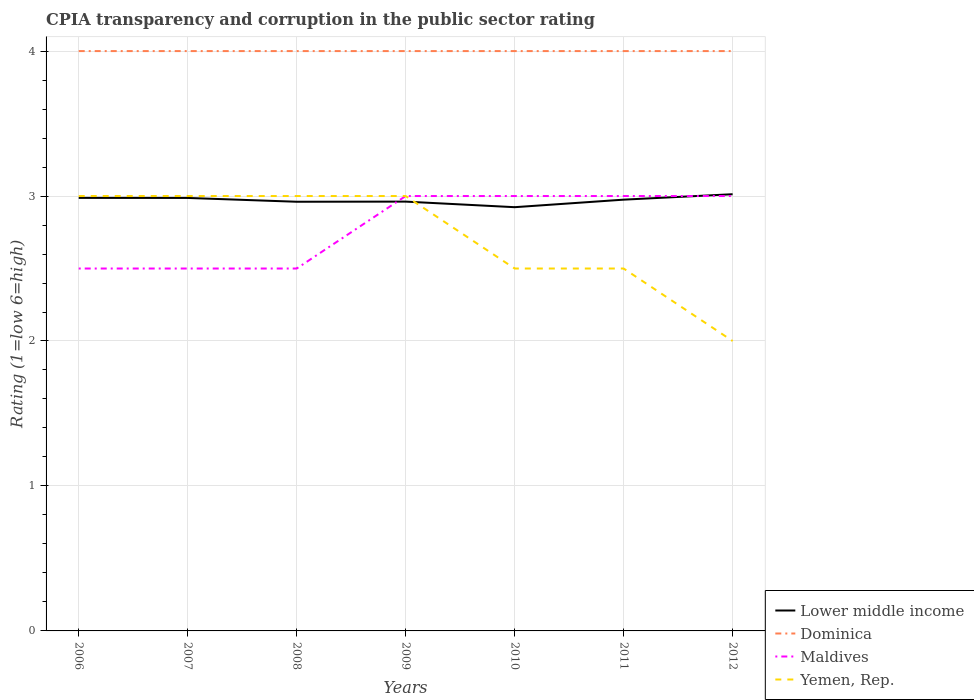Is the number of lines equal to the number of legend labels?
Your answer should be very brief. Yes. Across all years, what is the maximum CPIA rating in Lower middle income?
Your answer should be very brief. 2.92. In which year was the CPIA rating in Maldives maximum?
Ensure brevity in your answer.  2006. What is the total CPIA rating in Maldives in the graph?
Ensure brevity in your answer.  -0.5. What is the difference between the highest and the second highest CPIA rating in Lower middle income?
Provide a short and direct response. 0.09. What is the difference between the highest and the lowest CPIA rating in Maldives?
Offer a terse response. 4. Is the CPIA rating in Dominica strictly greater than the CPIA rating in Yemen, Rep. over the years?
Provide a succinct answer. No. How many years are there in the graph?
Your response must be concise. 7. What is the difference between two consecutive major ticks on the Y-axis?
Your answer should be compact. 1. Does the graph contain grids?
Provide a short and direct response. Yes. How are the legend labels stacked?
Make the answer very short. Vertical. What is the title of the graph?
Make the answer very short. CPIA transparency and corruption in the public sector rating. What is the label or title of the X-axis?
Your response must be concise. Years. What is the Rating (1=low 6=high) in Lower middle income in 2006?
Your response must be concise. 2.99. What is the Rating (1=low 6=high) of Dominica in 2006?
Offer a very short reply. 4. What is the Rating (1=low 6=high) of Yemen, Rep. in 2006?
Offer a very short reply. 3. What is the Rating (1=low 6=high) of Lower middle income in 2007?
Your answer should be compact. 2.99. What is the Rating (1=low 6=high) in Maldives in 2007?
Ensure brevity in your answer.  2.5. What is the Rating (1=low 6=high) in Yemen, Rep. in 2007?
Give a very brief answer. 3. What is the Rating (1=low 6=high) of Lower middle income in 2008?
Provide a short and direct response. 2.96. What is the Rating (1=low 6=high) of Maldives in 2008?
Provide a succinct answer. 2.5. What is the Rating (1=low 6=high) in Yemen, Rep. in 2008?
Offer a terse response. 3. What is the Rating (1=low 6=high) in Lower middle income in 2009?
Your response must be concise. 2.96. What is the Rating (1=low 6=high) of Maldives in 2009?
Offer a very short reply. 3. What is the Rating (1=low 6=high) in Lower middle income in 2010?
Provide a short and direct response. 2.92. What is the Rating (1=low 6=high) in Maldives in 2010?
Offer a terse response. 3. What is the Rating (1=low 6=high) of Yemen, Rep. in 2010?
Your answer should be compact. 2.5. What is the Rating (1=low 6=high) in Lower middle income in 2011?
Ensure brevity in your answer.  2.98. What is the Rating (1=low 6=high) in Maldives in 2011?
Ensure brevity in your answer.  3. What is the Rating (1=low 6=high) of Yemen, Rep. in 2011?
Make the answer very short. 2.5. What is the Rating (1=low 6=high) of Lower middle income in 2012?
Provide a short and direct response. 3.01. What is the Rating (1=low 6=high) of Yemen, Rep. in 2012?
Your answer should be compact. 2. Across all years, what is the maximum Rating (1=low 6=high) of Lower middle income?
Provide a succinct answer. 3.01. Across all years, what is the maximum Rating (1=low 6=high) of Dominica?
Your response must be concise. 4. Across all years, what is the maximum Rating (1=low 6=high) of Yemen, Rep.?
Your response must be concise. 3. Across all years, what is the minimum Rating (1=low 6=high) of Lower middle income?
Provide a succinct answer. 2.92. Across all years, what is the minimum Rating (1=low 6=high) of Maldives?
Keep it short and to the point. 2.5. Across all years, what is the minimum Rating (1=low 6=high) of Yemen, Rep.?
Provide a succinct answer. 2. What is the total Rating (1=low 6=high) in Lower middle income in the graph?
Offer a terse response. 20.81. What is the total Rating (1=low 6=high) in Maldives in the graph?
Provide a succinct answer. 19.5. What is the total Rating (1=low 6=high) in Yemen, Rep. in the graph?
Keep it short and to the point. 19. What is the difference between the Rating (1=low 6=high) in Yemen, Rep. in 2006 and that in 2007?
Give a very brief answer. 0. What is the difference between the Rating (1=low 6=high) in Lower middle income in 2006 and that in 2008?
Provide a short and direct response. 0.03. What is the difference between the Rating (1=low 6=high) in Yemen, Rep. in 2006 and that in 2008?
Give a very brief answer. 0. What is the difference between the Rating (1=low 6=high) of Lower middle income in 2006 and that in 2009?
Offer a terse response. 0.03. What is the difference between the Rating (1=low 6=high) of Dominica in 2006 and that in 2009?
Ensure brevity in your answer.  0. What is the difference between the Rating (1=low 6=high) in Maldives in 2006 and that in 2009?
Your response must be concise. -0.5. What is the difference between the Rating (1=low 6=high) in Lower middle income in 2006 and that in 2010?
Ensure brevity in your answer.  0.06. What is the difference between the Rating (1=low 6=high) in Yemen, Rep. in 2006 and that in 2010?
Your answer should be compact. 0.5. What is the difference between the Rating (1=low 6=high) in Lower middle income in 2006 and that in 2011?
Offer a very short reply. 0.01. What is the difference between the Rating (1=low 6=high) of Dominica in 2006 and that in 2011?
Your answer should be very brief. 0. What is the difference between the Rating (1=low 6=high) of Yemen, Rep. in 2006 and that in 2011?
Your response must be concise. 0.5. What is the difference between the Rating (1=low 6=high) of Lower middle income in 2006 and that in 2012?
Provide a short and direct response. -0.03. What is the difference between the Rating (1=low 6=high) in Lower middle income in 2007 and that in 2008?
Provide a succinct answer. 0.03. What is the difference between the Rating (1=low 6=high) of Yemen, Rep. in 2007 and that in 2008?
Your answer should be very brief. 0. What is the difference between the Rating (1=low 6=high) in Lower middle income in 2007 and that in 2009?
Your answer should be compact. 0.03. What is the difference between the Rating (1=low 6=high) in Maldives in 2007 and that in 2009?
Provide a short and direct response. -0.5. What is the difference between the Rating (1=low 6=high) in Yemen, Rep. in 2007 and that in 2009?
Offer a terse response. 0. What is the difference between the Rating (1=low 6=high) in Lower middle income in 2007 and that in 2010?
Your answer should be very brief. 0.06. What is the difference between the Rating (1=low 6=high) in Dominica in 2007 and that in 2010?
Offer a very short reply. 0. What is the difference between the Rating (1=low 6=high) of Lower middle income in 2007 and that in 2011?
Your answer should be compact. 0.01. What is the difference between the Rating (1=low 6=high) in Maldives in 2007 and that in 2011?
Ensure brevity in your answer.  -0.5. What is the difference between the Rating (1=low 6=high) of Yemen, Rep. in 2007 and that in 2011?
Keep it short and to the point. 0.5. What is the difference between the Rating (1=low 6=high) in Lower middle income in 2007 and that in 2012?
Ensure brevity in your answer.  -0.03. What is the difference between the Rating (1=low 6=high) in Dominica in 2007 and that in 2012?
Your answer should be compact. 0. What is the difference between the Rating (1=low 6=high) of Lower middle income in 2008 and that in 2009?
Your answer should be very brief. -0. What is the difference between the Rating (1=low 6=high) in Dominica in 2008 and that in 2009?
Offer a very short reply. 0. What is the difference between the Rating (1=low 6=high) in Maldives in 2008 and that in 2009?
Make the answer very short. -0.5. What is the difference between the Rating (1=low 6=high) in Lower middle income in 2008 and that in 2010?
Offer a very short reply. 0.04. What is the difference between the Rating (1=low 6=high) in Dominica in 2008 and that in 2010?
Your response must be concise. 0. What is the difference between the Rating (1=low 6=high) of Yemen, Rep. in 2008 and that in 2010?
Your answer should be compact. 0.5. What is the difference between the Rating (1=low 6=high) of Lower middle income in 2008 and that in 2011?
Your answer should be very brief. -0.01. What is the difference between the Rating (1=low 6=high) in Yemen, Rep. in 2008 and that in 2011?
Your answer should be very brief. 0.5. What is the difference between the Rating (1=low 6=high) of Lower middle income in 2008 and that in 2012?
Provide a succinct answer. -0.05. What is the difference between the Rating (1=low 6=high) in Maldives in 2008 and that in 2012?
Give a very brief answer. -0.5. What is the difference between the Rating (1=low 6=high) in Yemen, Rep. in 2008 and that in 2012?
Offer a very short reply. 1. What is the difference between the Rating (1=low 6=high) of Lower middle income in 2009 and that in 2010?
Ensure brevity in your answer.  0.04. What is the difference between the Rating (1=low 6=high) of Dominica in 2009 and that in 2010?
Offer a terse response. 0. What is the difference between the Rating (1=low 6=high) of Maldives in 2009 and that in 2010?
Your response must be concise. 0. What is the difference between the Rating (1=low 6=high) of Lower middle income in 2009 and that in 2011?
Make the answer very short. -0.01. What is the difference between the Rating (1=low 6=high) of Yemen, Rep. in 2009 and that in 2011?
Make the answer very short. 0.5. What is the difference between the Rating (1=low 6=high) in Lower middle income in 2009 and that in 2012?
Your answer should be very brief. -0.05. What is the difference between the Rating (1=low 6=high) in Yemen, Rep. in 2009 and that in 2012?
Offer a terse response. 1. What is the difference between the Rating (1=low 6=high) in Lower middle income in 2010 and that in 2011?
Your response must be concise. -0.05. What is the difference between the Rating (1=low 6=high) of Dominica in 2010 and that in 2011?
Provide a short and direct response. 0. What is the difference between the Rating (1=low 6=high) of Maldives in 2010 and that in 2011?
Offer a very short reply. 0. What is the difference between the Rating (1=low 6=high) in Lower middle income in 2010 and that in 2012?
Your answer should be very brief. -0.09. What is the difference between the Rating (1=low 6=high) in Lower middle income in 2011 and that in 2012?
Provide a succinct answer. -0.04. What is the difference between the Rating (1=low 6=high) in Dominica in 2011 and that in 2012?
Provide a succinct answer. 0. What is the difference between the Rating (1=low 6=high) of Maldives in 2011 and that in 2012?
Keep it short and to the point. 0. What is the difference between the Rating (1=low 6=high) in Lower middle income in 2006 and the Rating (1=low 6=high) in Dominica in 2007?
Make the answer very short. -1.01. What is the difference between the Rating (1=low 6=high) in Lower middle income in 2006 and the Rating (1=low 6=high) in Maldives in 2007?
Your answer should be compact. 0.49. What is the difference between the Rating (1=low 6=high) in Lower middle income in 2006 and the Rating (1=low 6=high) in Yemen, Rep. in 2007?
Your response must be concise. -0.01. What is the difference between the Rating (1=low 6=high) of Dominica in 2006 and the Rating (1=low 6=high) of Yemen, Rep. in 2007?
Your answer should be compact. 1. What is the difference between the Rating (1=low 6=high) in Lower middle income in 2006 and the Rating (1=low 6=high) in Dominica in 2008?
Give a very brief answer. -1.01. What is the difference between the Rating (1=low 6=high) of Lower middle income in 2006 and the Rating (1=low 6=high) of Maldives in 2008?
Ensure brevity in your answer.  0.49. What is the difference between the Rating (1=low 6=high) of Lower middle income in 2006 and the Rating (1=low 6=high) of Yemen, Rep. in 2008?
Your response must be concise. -0.01. What is the difference between the Rating (1=low 6=high) of Dominica in 2006 and the Rating (1=low 6=high) of Maldives in 2008?
Offer a very short reply. 1.5. What is the difference between the Rating (1=low 6=high) in Lower middle income in 2006 and the Rating (1=low 6=high) in Dominica in 2009?
Offer a terse response. -1.01. What is the difference between the Rating (1=low 6=high) of Lower middle income in 2006 and the Rating (1=low 6=high) of Maldives in 2009?
Offer a very short reply. -0.01. What is the difference between the Rating (1=low 6=high) of Lower middle income in 2006 and the Rating (1=low 6=high) of Yemen, Rep. in 2009?
Provide a succinct answer. -0.01. What is the difference between the Rating (1=low 6=high) in Dominica in 2006 and the Rating (1=low 6=high) in Maldives in 2009?
Your response must be concise. 1. What is the difference between the Rating (1=low 6=high) of Lower middle income in 2006 and the Rating (1=low 6=high) of Dominica in 2010?
Provide a short and direct response. -1.01. What is the difference between the Rating (1=low 6=high) in Lower middle income in 2006 and the Rating (1=low 6=high) in Maldives in 2010?
Offer a very short reply. -0.01. What is the difference between the Rating (1=low 6=high) in Lower middle income in 2006 and the Rating (1=low 6=high) in Yemen, Rep. in 2010?
Provide a short and direct response. 0.49. What is the difference between the Rating (1=low 6=high) of Dominica in 2006 and the Rating (1=low 6=high) of Maldives in 2010?
Make the answer very short. 1. What is the difference between the Rating (1=low 6=high) of Dominica in 2006 and the Rating (1=low 6=high) of Yemen, Rep. in 2010?
Your answer should be compact. 1.5. What is the difference between the Rating (1=low 6=high) of Lower middle income in 2006 and the Rating (1=low 6=high) of Dominica in 2011?
Your answer should be very brief. -1.01. What is the difference between the Rating (1=low 6=high) in Lower middle income in 2006 and the Rating (1=low 6=high) in Maldives in 2011?
Offer a very short reply. -0.01. What is the difference between the Rating (1=low 6=high) in Lower middle income in 2006 and the Rating (1=low 6=high) in Yemen, Rep. in 2011?
Give a very brief answer. 0.49. What is the difference between the Rating (1=low 6=high) of Dominica in 2006 and the Rating (1=low 6=high) of Maldives in 2011?
Make the answer very short. 1. What is the difference between the Rating (1=low 6=high) in Lower middle income in 2006 and the Rating (1=low 6=high) in Dominica in 2012?
Offer a very short reply. -1.01. What is the difference between the Rating (1=low 6=high) in Lower middle income in 2006 and the Rating (1=low 6=high) in Maldives in 2012?
Your answer should be compact. -0.01. What is the difference between the Rating (1=low 6=high) in Lower middle income in 2006 and the Rating (1=low 6=high) in Yemen, Rep. in 2012?
Keep it short and to the point. 0.99. What is the difference between the Rating (1=low 6=high) in Dominica in 2006 and the Rating (1=low 6=high) in Maldives in 2012?
Provide a succinct answer. 1. What is the difference between the Rating (1=low 6=high) of Dominica in 2006 and the Rating (1=low 6=high) of Yemen, Rep. in 2012?
Your answer should be very brief. 2. What is the difference between the Rating (1=low 6=high) of Maldives in 2006 and the Rating (1=low 6=high) of Yemen, Rep. in 2012?
Your answer should be compact. 0.5. What is the difference between the Rating (1=low 6=high) in Lower middle income in 2007 and the Rating (1=low 6=high) in Dominica in 2008?
Provide a succinct answer. -1.01. What is the difference between the Rating (1=low 6=high) in Lower middle income in 2007 and the Rating (1=low 6=high) in Maldives in 2008?
Your answer should be compact. 0.49. What is the difference between the Rating (1=low 6=high) of Lower middle income in 2007 and the Rating (1=low 6=high) of Yemen, Rep. in 2008?
Your answer should be compact. -0.01. What is the difference between the Rating (1=low 6=high) of Dominica in 2007 and the Rating (1=low 6=high) of Yemen, Rep. in 2008?
Your response must be concise. 1. What is the difference between the Rating (1=low 6=high) in Maldives in 2007 and the Rating (1=low 6=high) in Yemen, Rep. in 2008?
Your response must be concise. -0.5. What is the difference between the Rating (1=low 6=high) of Lower middle income in 2007 and the Rating (1=low 6=high) of Dominica in 2009?
Keep it short and to the point. -1.01. What is the difference between the Rating (1=low 6=high) of Lower middle income in 2007 and the Rating (1=low 6=high) of Maldives in 2009?
Make the answer very short. -0.01. What is the difference between the Rating (1=low 6=high) in Lower middle income in 2007 and the Rating (1=low 6=high) in Yemen, Rep. in 2009?
Provide a short and direct response. -0.01. What is the difference between the Rating (1=low 6=high) of Dominica in 2007 and the Rating (1=low 6=high) of Maldives in 2009?
Provide a short and direct response. 1. What is the difference between the Rating (1=low 6=high) in Dominica in 2007 and the Rating (1=low 6=high) in Yemen, Rep. in 2009?
Your answer should be very brief. 1. What is the difference between the Rating (1=low 6=high) of Lower middle income in 2007 and the Rating (1=low 6=high) of Dominica in 2010?
Your answer should be compact. -1.01. What is the difference between the Rating (1=low 6=high) in Lower middle income in 2007 and the Rating (1=low 6=high) in Maldives in 2010?
Your answer should be very brief. -0.01. What is the difference between the Rating (1=low 6=high) in Lower middle income in 2007 and the Rating (1=low 6=high) in Yemen, Rep. in 2010?
Keep it short and to the point. 0.49. What is the difference between the Rating (1=low 6=high) of Dominica in 2007 and the Rating (1=low 6=high) of Maldives in 2010?
Make the answer very short. 1. What is the difference between the Rating (1=low 6=high) of Maldives in 2007 and the Rating (1=low 6=high) of Yemen, Rep. in 2010?
Provide a short and direct response. 0. What is the difference between the Rating (1=low 6=high) of Lower middle income in 2007 and the Rating (1=low 6=high) of Dominica in 2011?
Provide a succinct answer. -1.01. What is the difference between the Rating (1=low 6=high) of Lower middle income in 2007 and the Rating (1=low 6=high) of Maldives in 2011?
Offer a terse response. -0.01. What is the difference between the Rating (1=low 6=high) in Lower middle income in 2007 and the Rating (1=low 6=high) in Yemen, Rep. in 2011?
Your answer should be very brief. 0.49. What is the difference between the Rating (1=low 6=high) in Lower middle income in 2007 and the Rating (1=low 6=high) in Dominica in 2012?
Make the answer very short. -1.01. What is the difference between the Rating (1=low 6=high) in Lower middle income in 2007 and the Rating (1=low 6=high) in Maldives in 2012?
Give a very brief answer. -0.01. What is the difference between the Rating (1=low 6=high) of Dominica in 2007 and the Rating (1=low 6=high) of Yemen, Rep. in 2012?
Offer a very short reply. 2. What is the difference between the Rating (1=low 6=high) of Maldives in 2007 and the Rating (1=low 6=high) of Yemen, Rep. in 2012?
Provide a short and direct response. 0.5. What is the difference between the Rating (1=low 6=high) in Lower middle income in 2008 and the Rating (1=low 6=high) in Dominica in 2009?
Ensure brevity in your answer.  -1.04. What is the difference between the Rating (1=low 6=high) of Lower middle income in 2008 and the Rating (1=low 6=high) of Maldives in 2009?
Keep it short and to the point. -0.04. What is the difference between the Rating (1=low 6=high) in Lower middle income in 2008 and the Rating (1=low 6=high) in Yemen, Rep. in 2009?
Offer a terse response. -0.04. What is the difference between the Rating (1=low 6=high) in Maldives in 2008 and the Rating (1=low 6=high) in Yemen, Rep. in 2009?
Your response must be concise. -0.5. What is the difference between the Rating (1=low 6=high) of Lower middle income in 2008 and the Rating (1=low 6=high) of Dominica in 2010?
Provide a succinct answer. -1.04. What is the difference between the Rating (1=low 6=high) of Lower middle income in 2008 and the Rating (1=low 6=high) of Maldives in 2010?
Your answer should be compact. -0.04. What is the difference between the Rating (1=low 6=high) in Lower middle income in 2008 and the Rating (1=low 6=high) in Yemen, Rep. in 2010?
Ensure brevity in your answer.  0.46. What is the difference between the Rating (1=low 6=high) in Dominica in 2008 and the Rating (1=low 6=high) in Maldives in 2010?
Offer a terse response. 1. What is the difference between the Rating (1=low 6=high) in Maldives in 2008 and the Rating (1=low 6=high) in Yemen, Rep. in 2010?
Make the answer very short. 0. What is the difference between the Rating (1=low 6=high) of Lower middle income in 2008 and the Rating (1=low 6=high) of Dominica in 2011?
Your response must be concise. -1.04. What is the difference between the Rating (1=low 6=high) in Lower middle income in 2008 and the Rating (1=low 6=high) in Maldives in 2011?
Offer a terse response. -0.04. What is the difference between the Rating (1=low 6=high) in Lower middle income in 2008 and the Rating (1=low 6=high) in Yemen, Rep. in 2011?
Provide a succinct answer. 0.46. What is the difference between the Rating (1=low 6=high) of Dominica in 2008 and the Rating (1=low 6=high) of Yemen, Rep. in 2011?
Provide a succinct answer. 1.5. What is the difference between the Rating (1=low 6=high) of Lower middle income in 2008 and the Rating (1=low 6=high) of Dominica in 2012?
Your answer should be compact. -1.04. What is the difference between the Rating (1=low 6=high) of Lower middle income in 2008 and the Rating (1=low 6=high) of Maldives in 2012?
Provide a succinct answer. -0.04. What is the difference between the Rating (1=low 6=high) of Lower middle income in 2008 and the Rating (1=low 6=high) of Yemen, Rep. in 2012?
Make the answer very short. 0.96. What is the difference between the Rating (1=low 6=high) of Dominica in 2008 and the Rating (1=low 6=high) of Yemen, Rep. in 2012?
Your answer should be very brief. 2. What is the difference between the Rating (1=low 6=high) of Maldives in 2008 and the Rating (1=low 6=high) of Yemen, Rep. in 2012?
Your answer should be compact. 0.5. What is the difference between the Rating (1=low 6=high) of Lower middle income in 2009 and the Rating (1=low 6=high) of Dominica in 2010?
Keep it short and to the point. -1.04. What is the difference between the Rating (1=low 6=high) in Lower middle income in 2009 and the Rating (1=low 6=high) in Maldives in 2010?
Your answer should be compact. -0.04. What is the difference between the Rating (1=low 6=high) of Lower middle income in 2009 and the Rating (1=low 6=high) of Yemen, Rep. in 2010?
Your answer should be compact. 0.46. What is the difference between the Rating (1=low 6=high) of Dominica in 2009 and the Rating (1=low 6=high) of Yemen, Rep. in 2010?
Offer a terse response. 1.5. What is the difference between the Rating (1=low 6=high) in Maldives in 2009 and the Rating (1=low 6=high) in Yemen, Rep. in 2010?
Ensure brevity in your answer.  0.5. What is the difference between the Rating (1=low 6=high) of Lower middle income in 2009 and the Rating (1=low 6=high) of Dominica in 2011?
Make the answer very short. -1.04. What is the difference between the Rating (1=low 6=high) in Lower middle income in 2009 and the Rating (1=low 6=high) in Maldives in 2011?
Your answer should be compact. -0.04. What is the difference between the Rating (1=low 6=high) in Lower middle income in 2009 and the Rating (1=low 6=high) in Yemen, Rep. in 2011?
Make the answer very short. 0.46. What is the difference between the Rating (1=low 6=high) in Dominica in 2009 and the Rating (1=low 6=high) in Maldives in 2011?
Keep it short and to the point. 1. What is the difference between the Rating (1=low 6=high) in Maldives in 2009 and the Rating (1=low 6=high) in Yemen, Rep. in 2011?
Keep it short and to the point. 0.5. What is the difference between the Rating (1=low 6=high) of Lower middle income in 2009 and the Rating (1=low 6=high) of Dominica in 2012?
Offer a terse response. -1.04. What is the difference between the Rating (1=low 6=high) in Lower middle income in 2009 and the Rating (1=low 6=high) in Maldives in 2012?
Give a very brief answer. -0.04. What is the difference between the Rating (1=low 6=high) of Lower middle income in 2009 and the Rating (1=low 6=high) of Yemen, Rep. in 2012?
Your answer should be very brief. 0.96. What is the difference between the Rating (1=low 6=high) in Dominica in 2009 and the Rating (1=low 6=high) in Maldives in 2012?
Your answer should be very brief. 1. What is the difference between the Rating (1=low 6=high) in Lower middle income in 2010 and the Rating (1=low 6=high) in Dominica in 2011?
Keep it short and to the point. -1.08. What is the difference between the Rating (1=low 6=high) of Lower middle income in 2010 and the Rating (1=low 6=high) of Maldives in 2011?
Keep it short and to the point. -0.08. What is the difference between the Rating (1=low 6=high) in Lower middle income in 2010 and the Rating (1=low 6=high) in Yemen, Rep. in 2011?
Provide a short and direct response. 0.42. What is the difference between the Rating (1=low 6=high) in Dominica in 2010 and the Rating (1=low 6=high) in Maldives in 2011?
Make the answer very short. 1. What is the difference between the Rating (1=low 6=high) of Maldives in 2010 and the Rating (1=low 6=high) of Yemen, Rep. in 2011?
Give a very brief answer. 0.5. What is the difference between the Rating (1=low 6=high) in Lower middle income in 2010 and the Rating (1=low 6=high) in Dominica in 2012?
Offer a terse response. -1.08. What is the difference between the Rating (1=low 6=high) of Lower middle income in 2010 and the Rating (1=low 6=high) of Maldives in 2012?
Keep it short and to the point. -0.08. What is the difference between the Rating (1=low 6=high) of Dominica in 2010 and the Rating (1=low 6=high) of Maldives in 2012?
Your answer should be compact. 1. What is the difference between the Rating (1=low 6=high) in Maldives in 2010 and the Rating (1=low 6=high) in Yemen, Rep. in 2012?
Provide a short and direct response. 1. What is the difference between the Rating (1=low 6=high) in Lower middle income in 2011 and the Rating (1=low 6=high) in Dominica in 2012?
Your answer should be compact. -1.02. What is the difference between the Rating (1=low 6=high) of Lower middle income in 2011 and the Rating (1=low 6=high) of Maldives in 2012?
Ensure brevity in your answer.  -0.03. What is the difference between the Rating (1=low 6=high) of Maldives in 2011 and the Rating (1=low 6=high) of Yemen, Rep. in 2012?
Provide a short and direct response. 1. What is the average Rating (1=low 6=high) in Lower middle income per year?
Make the answer very short. 2.97. What is the average Rating (1=low 6=high) of Maldives per year?
Ensure brevity in your answer.  2.79. What is the average Rating (1=low 6=high) in Yemen, Rep. per year?
Offer a very short reply. 2.71. In the year 2006, what is the difference between the Rating (1=low 6=high) of Lower middle income and Rating (1=low 6=high) of Dominica?
Make the answer very short. -1.01. In the year 2006, what is the difference between the Rating (1=low 6=high) in Lower middle income and Rating (1=low 6=high) in Maldives?
Ensure brevity in your answer.  0.49. In the year 2006, what is the difference between the Rating (1=low 6=high) in Lower middle income and Rating (1=low 6=high) in Yemen, Rep.?
Your response must be concise. -0.01. In the year 2006, what is the difference between the Rating (1=low 6=high) in Maldives and Rating (1=low 6=high) in Yemen, Rep.?
Provide a succinct answer. -0.5. In the year 2007, what is the difference between the Rating (1=low 6=high) of Lower middle income and Rating (1=low 6=high) of Dominica?
Provide a succinct answer. -1.01. In the year 2007, what is the difference between the Rating (1=low 6=high) in Lower middle income and Rating (1=low 6=high) in Maldives?
Offer a very short reply. 0.49. In the year 2007, what is the difference between the Rating (1=low 6=high) of Lower middle income and Rating (1=low 6=high) of Yemen, Rep.?
Ensure brevity in your answer.  -0.01. In the year 2007, what is the difference between the Rating (1=low 6=high) in Dominica and Rating (1=low 6=high) in Yemen, Rep.?
Provide a succinct answer. 1. In the year 2008, what is the difference between the Rating (1=low 6=high) of Lower middle income and Rating (1=low 6=high) of Dominica?
Give a very brief answer. -1.04. In the year 2008, what is the difference between the Rating (1=low 6=high) in Lower middle income and Rating (1=low 6=high) in Maldives?
Offer a terse response. 0.46. In the year 2008, what is the difference between the Rating (1=low 6=high) in Lower middle income and Rating (1=low 6=high) in Yemen, Rep.?
Provide a short and direct response. -0.04. In the year 2008, what is the difference between the Rating (1=low 6=high) in Maldives and Rating (1=low 6=high) in Yemen, Rep.?
Your response must be concise. -0.5. In the year 2009, what is the difference between the Rating (1=low 6=high) of Lower middle income and Rating (1=low 6=high) of Dominica?
Provide a succinct answer. -1.04. In the year 2009, what is the difference between the Rating (1=low 6=high) in Lower middle income and Rating (1=low 6=high) in Maldives?
Provide a succinct answer. -0.04. In the year 2009, what is the difference between the Rating (1=low 6=high) in Lower middle income and Rating (1=low 6=high) in Yemen, Rep.?
Make the answer very short. -0.04. In the year 2009, what is the difference between the Rating (1=low 6=high) in Dominica and Rating (1=low 6=high) in Yemen, Rep.?
Offer a terse response. 1. In the year 2009, what is the difference between the Rating (1=low 6=high) of Maldives and Rating (1=low 6=high) of Yemen, Rep.?
Offer a very short reply. 0. In the year 2010, what is the difference between the Rating (1=low 6=high) in Lower middle income and Rating (1=low 6=high) in Dominica?
Make the answer very short. -1.08. In the year 2010, what is the difference between the Rating (1=low 6=high) in Lower middle income and Rating (1=low 6=high) in Maldives?
Provide a succinct answer. -0.08. In the year 2010, what is the difference between the Rating (1=low 6=high) of Lower middle income and Rating (1=low 6=high) of Yemen, Rep.?
Your response must be concise. 0.42. In the year 2010, what is the difference between the Rating (1=low 6=high) in Dominica and Rating (1=low 6=high) in Maldives?
Keep it short and to the point. 1. In the year 2010, what is the difference between the Rating (1=low 6=high) in Dominica and Rating (1=low 6=high) in Yemen, Rep.?
Your answer should be very brief. 1.5. In the year 2010, what is the difference between the Rating (1=low 6=high) in Maldives and Rating (1=low 6=high) in Yemen, Rep.?
Ensure brevity in your answer.  0.5. In the year 2011, what is the difference between the Rating (1=low 6=high) of Lower middle income and Rating (1=low 6=high) of Dominica?
Provide a short and direct response. -1.02. In the year 2011, what is the difference between the Rating (1=low 6=high) of Lower middle income and Rating (1=low 6=high) of Maldives?
Keep it short and to the point. -0.03. In the year 2011, what is the difference between the Rating (1=low 6=high) in Lower middle income and Rating (1=low 6=high) in Yemen, Rep.?
Ensure brevity in your answer.  0.47. In the year 2011, what is the difference between the Rating (1=low 6=high) in Dominica and Rating (1=low 6=high) in Yemen, Rep.?
Your answer should be compact. 1.5. In the year 2012, what is the difference between the Rating (1=low 6=high) of Lower middle income and Rating (1=low 6=high) of Dominica?
Keep it short and to the point. -0.99. In the year 2012, what is the difference between the Rating (1=low 6=high) of Lower middle income and Rating (1=low 6=high) of Maldives?
Your answer should be compact. 0.01. In the year 2012, what is the difference between the Rating (1=low 6=high) of Lower middle income and Rating (1=low 6=high) of Yemen, Rep.?
Your answer should be very brief. 1.01. In the year 2012, what is the difference between the Rating (1=low 6=high) of Dominica and Rating (1=low 6=high) of Maldives?
Your answer should be compact. 1. What is the ratio of the Rating (1=low 6=high) in Lower middle income in 2006 to that in 2007?
Provide a short and direct response. 1. What is the ratio of the Rating (1=low 6=high) in Dominica in 2006 to that in 2007?
Keep it short and to the point. 1. What is the ratio of the Rating (1=low 6=high) of Maldives in 2006 to that in 2007?
Your answer should be very brief. 1. What is the ratio of the Rating (1=low 6=high) in Yemen, Rep. in 2006 to that in 2007?
Keep it short and to the point. 1. What is the ratio of the Rating (1=low 6=high) of Dominica in 2006 to that in 2008?
Ensure brevity in your answer.  1. What is the ratio of the Rating (1=low 6=high) in Lower middle income in 2006 to that in 2009?
Your answer should be compact. 1.01. What is the ratio of the Rating (1=low 6=high) in Maldives in 2006 to that in 2009?
Provide a succinct answer. 0.83. What is the ratio of the Rating (1=low 6=high) of Yemen, Rep. in 2006 to that in 2009?
Give a very brief answer. 1. What is the ratio of the Rating (1=low 6=high) in Lower middle income in 2006 to that in 2010?
Ensure brevity in your answer.  1.02. What is the ratio of the Rating (1=low 6=high) of Dominica in 2006 to that in 2010?
Make the answer very short. 1. What is the ratio of the Rating (1=low 6=high) in Lower middle income in 2006 to that in 2011?
Your response must be concise. 1. What is the ratio of the Rating (1=low 6=high) in Dominica in 2006 to that in 2011?
Your response must be concise. 1. What is the ratio of the Rating (1=low 6=high) of Yemen, Rep. in 2006 to that in 2011?
Provide a short and direct response. 1.2. What is the ratio of the Rating (1=low 6=high) in Lower middle income in 2006 to that in 2012?
Your response must be concise. 0.99. What is the ratio of the Rating (1=low 6=high) in Lower middle income in 2007 to that in 2008?
Make the answer very short. 1.01. What is the ratio of the Rating (1=low 6=high) of Lower middle income in 2007 to that in 2009?
Keep it short and to the point. 1.01. What is the ratio of the Rating (1=low 6=high) in Yemen, Rep. in 2007 to that in 2009?
Offer a very short reply. 1. What is the ratio of the Rating (1=low 6=high) of Lower middle income in 2007 to that in 2010?
Your answer should be compact. 1.02. What is the ratio of the Rating (1=low 6=high) of Dominica in 2007 to that in 2011?
Offer a very short reply. 1. What is the ratio of the Rating (1=low 6=high) of Lower middle income in 2007 to that in 2012?
Offer a terse response. 0.99. What is the ratio of the Rating (1=low 6=high) of Lower middle income in 2008 to that in 2009?
Ensure brevity in your answer.  1. What is the ratio of the Rating (1=low 6=high) of Dominica in 2008 to that in 2009?
Provide a succinct answer. 1. What is the ratio of the Rating (1=low 6=high) of Maldives in 2008 to that in 2009?
Your response must be concise. 0.83. What is the ratio of the Rating (1=low 6=high) of Lower middle income in 2008 to that in 2010?
Offer a terse response. 1.01. What is the ratio of the Rating (1=low 6=high) in Yemen, Rep. in 2008 to that in 2010?
Offer a very short reply. 1.2. What is the ratio of the Rating (1=low 6=high) of Dominica in 2008 to that in 2011?
Provide a succinct answer. 1. What is the ratio of the Rating (1=low 6=high) of Maldives in 2008 to that in 2011?
Keep it short and to the point. 0.83. What is the ratio of the Rating (1=low 6=high) of Yemen, Rep. in 2008 to that in 2011?
Give a very brief answer. 1.2. What is the ratio of the Rating (1=low 6=high) of Lower middle income in 2008 to that in 2012?
Provide a short and direct response. 0.98. What is the ratio of the Rating (1=low 6=high) of Lower middle income in 2009 to that in 2010?
Your answer should be very brief. 1.01. What is the ratio of the Rating (1=low 6=high) in Maldives in 2009 to that in 2010?
Provide a succinct answer. 1. What is the ratio of the Rating (1=low 6=high) in Dominica in 2009 to that in 2011?
Offer a very short reply. 1. What is the ratio of the Rating (1=low 6=high) in Yemen, Rep. in 2009 to that in 2011?
Your answer should be compact. 1.2. What is the ratio of the Rating (1=low 6=high) in Lower middle income in 2009 to that in 2012?
Provide a short and direct response. 0.98. What is the ratio of the Rating (1=low 6=high) of Lower middle income in 2010 to that in 2011?
Keep it short and to the point. 0.98. What is the ratio of the Rating (1=low 6=high) of Maldives in 2010 to that in 2011?
Offer a terse response. 1. What is the ratio of the Rating (1=low 6=high) of Yemen, Rep. in 2010 to that in 2011?
Provide a short and direct response. 1. What is the ratio of the Rating (1=low 6=high) in Lower middle income in 2010 to that in 2012?
Make the answer very short. 0.97. What is the ratio of the Rating (1=low 6=high) in Dominica in 2010 to that in 2012?
Offer a terse response. 1. What is the ratio of the Rating (1=low 6=high) in Maldives in 2010 to that in 2012?
Provide a short and direct response. 1. What is the ratio of the Rating (1=low 6=high) of Yemen, Rep. in 2010 to that in 2012?
Your answer should be very brief. 1.25. What is the ratio of the Rating (1=low 6=high) of Lower middle income in 2011 to that in 2012?
Your response must be concise. 0.99. What is the ratio of the Rating (1=low 6=high) in Dominica in 2011 to that in 2012?
Your answer should be compact. 1. What is the ratio of the Rating (1=low 6=high) of Maldives in 2011 to that in 2012?
Your answer should be very brief. 1. What is the difference between the highest and the second highest Rating (1=low 6=high) of Lower middle income?
Your response must be concise. 0.03. What is the difference between the highest and the second highest Rating (1=low 6=high) in Maldives?
Your response must be concise. 0. What is the difference between the highest and the second highest Rating (1=low 6=high) in Yemen, Rep.?
Give a very brief answer. 0. What is the difference between the highest and the lowest Rating (1=low 6=high) in Lower middle income?
Your answer should be compact. 0.09. What is the difference between the highest and the lowest Rating (1=low 6=high) in Dominica?
Ensure brevity in your answer.  0. What is the difference between the highest and the lowest Rating (1=low 6=high) of Yemen, Rep.?
Give a very brief answer. 1. 